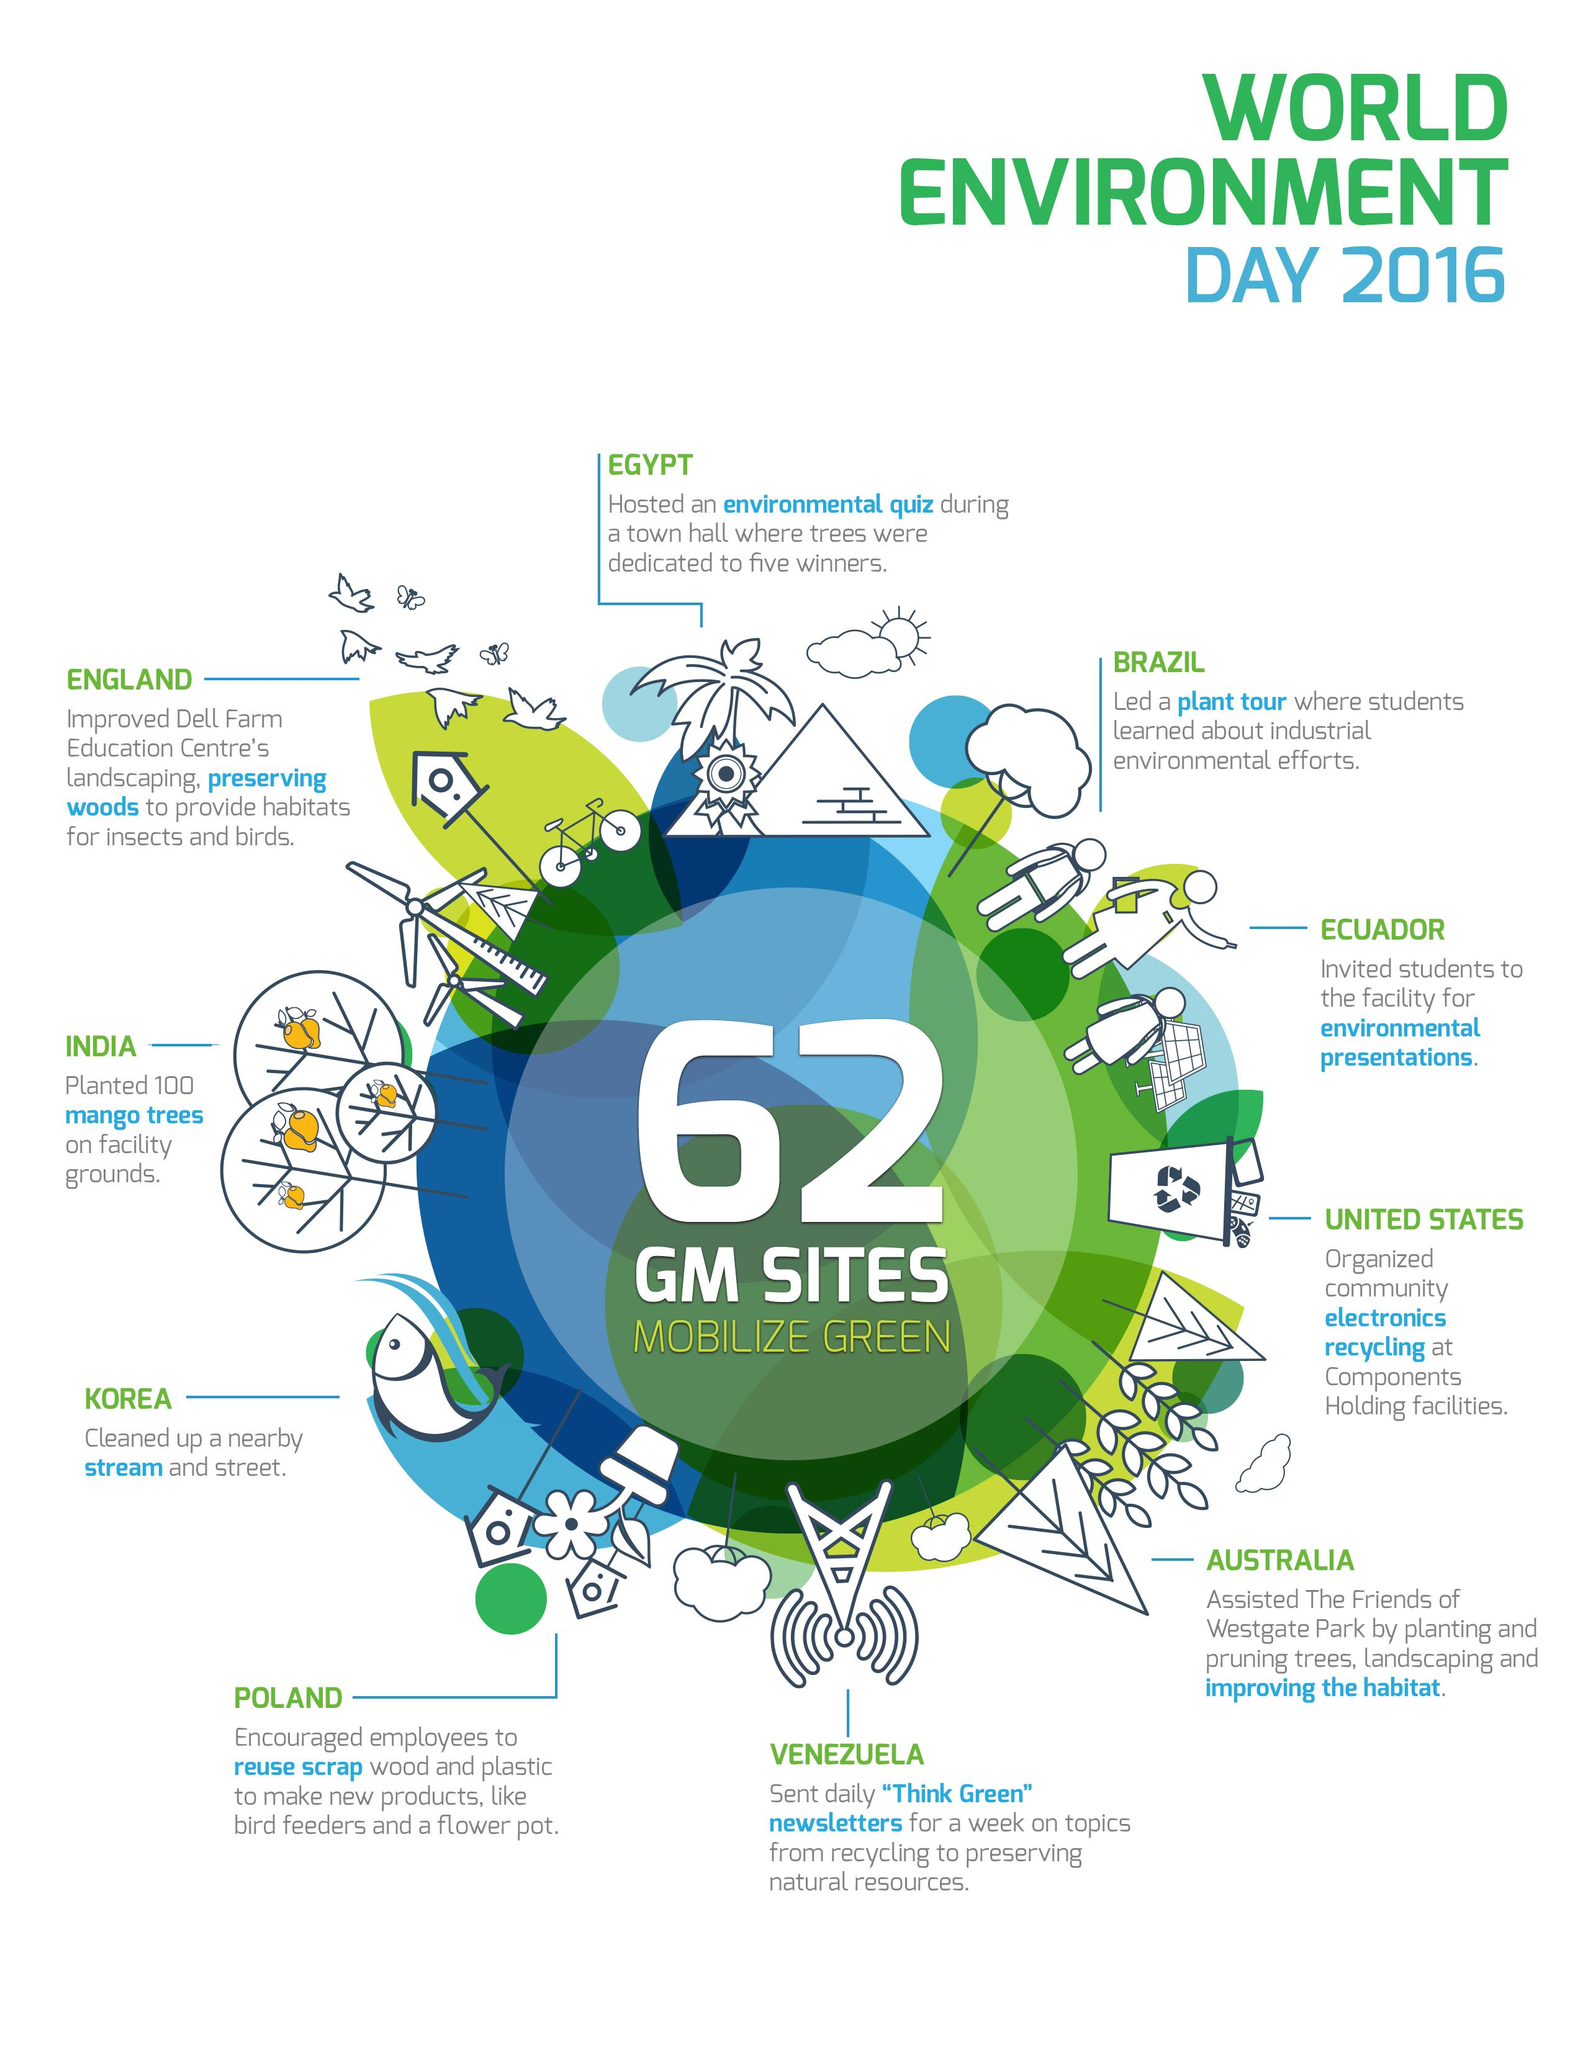Mention a couple of crucial points in this snapshot. On the occasion of the World Environment Day in 2016, India planted 100 mango trees on the facility ground. On World Environment Day 2016, Brazil led a plant tour for students, showcasing its commitment to promoting environmental awareness and preserving natural resources. On World Environment Day 2016, the country of Korea conducted a cleanup of a nearby stream and street. 